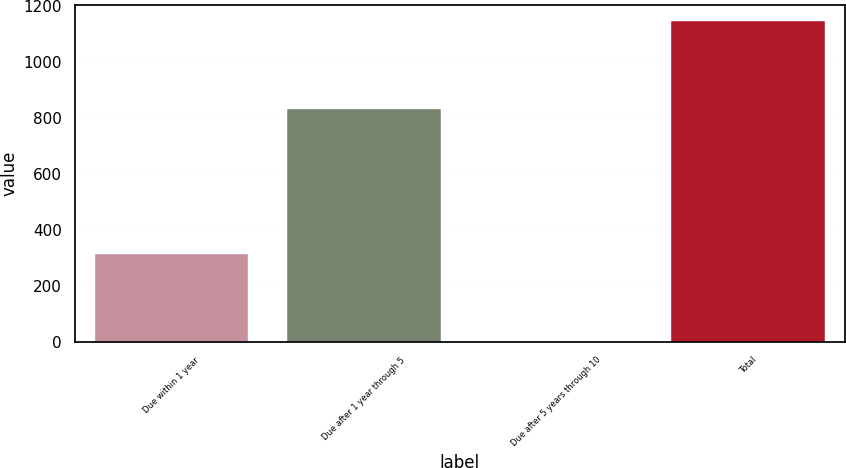<chart> <loc_0><loc_0><loc_500><loc_500><bar_chart><fcel>Due within 1 year<fcel>Due after 1 year through 5<fcel>Due after 5 years through 10<fcel>Total<nl><fcel>314<fcel>833<fcel>1<fcel>1149<nl></chart> 